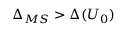Convert formula to latex. <formula><loc_0><loc_0><loc_500><loc_500>\Delta _ { M S } > \Delta ( U _ { 0 } )</formula> 